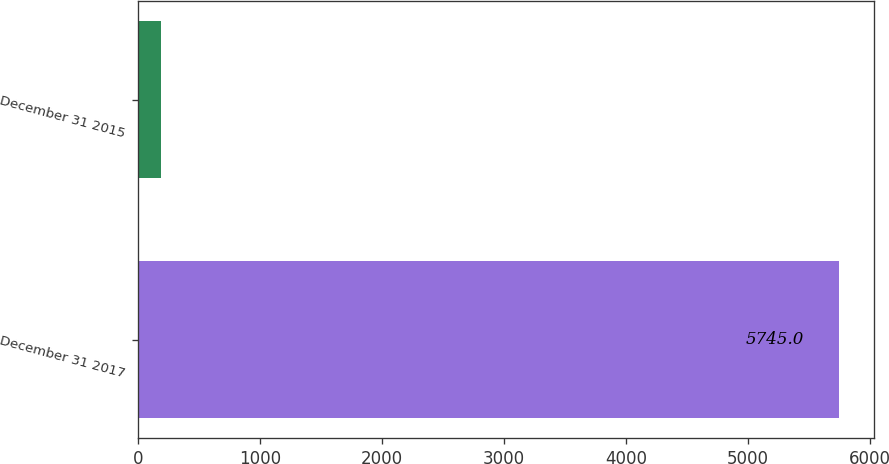<chart> <loc_0><loc_0><loc_500><loc_500><bar_chart><fcel>December 31 2017<fcel>December 31 2015<nl><fcel>5745<fcel>190<nl></chart> 